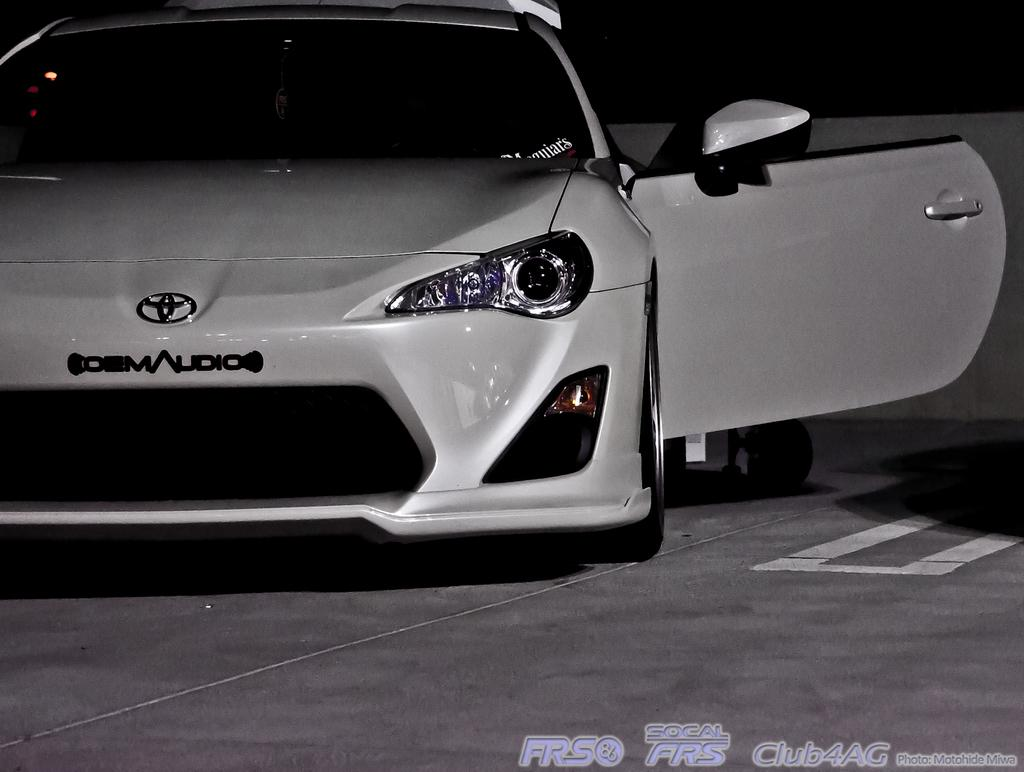What is the main subject of the image? There is a car in the image. What is the state of the car's door? The door of the car is opened. Is there any text visible in the image? Yes, there is some text in the bottom right corner of the image. What color is the cherry that is hanging from the car's door handle in the image? There is no cherry present in the image, and therefore no such detail can be observed. 